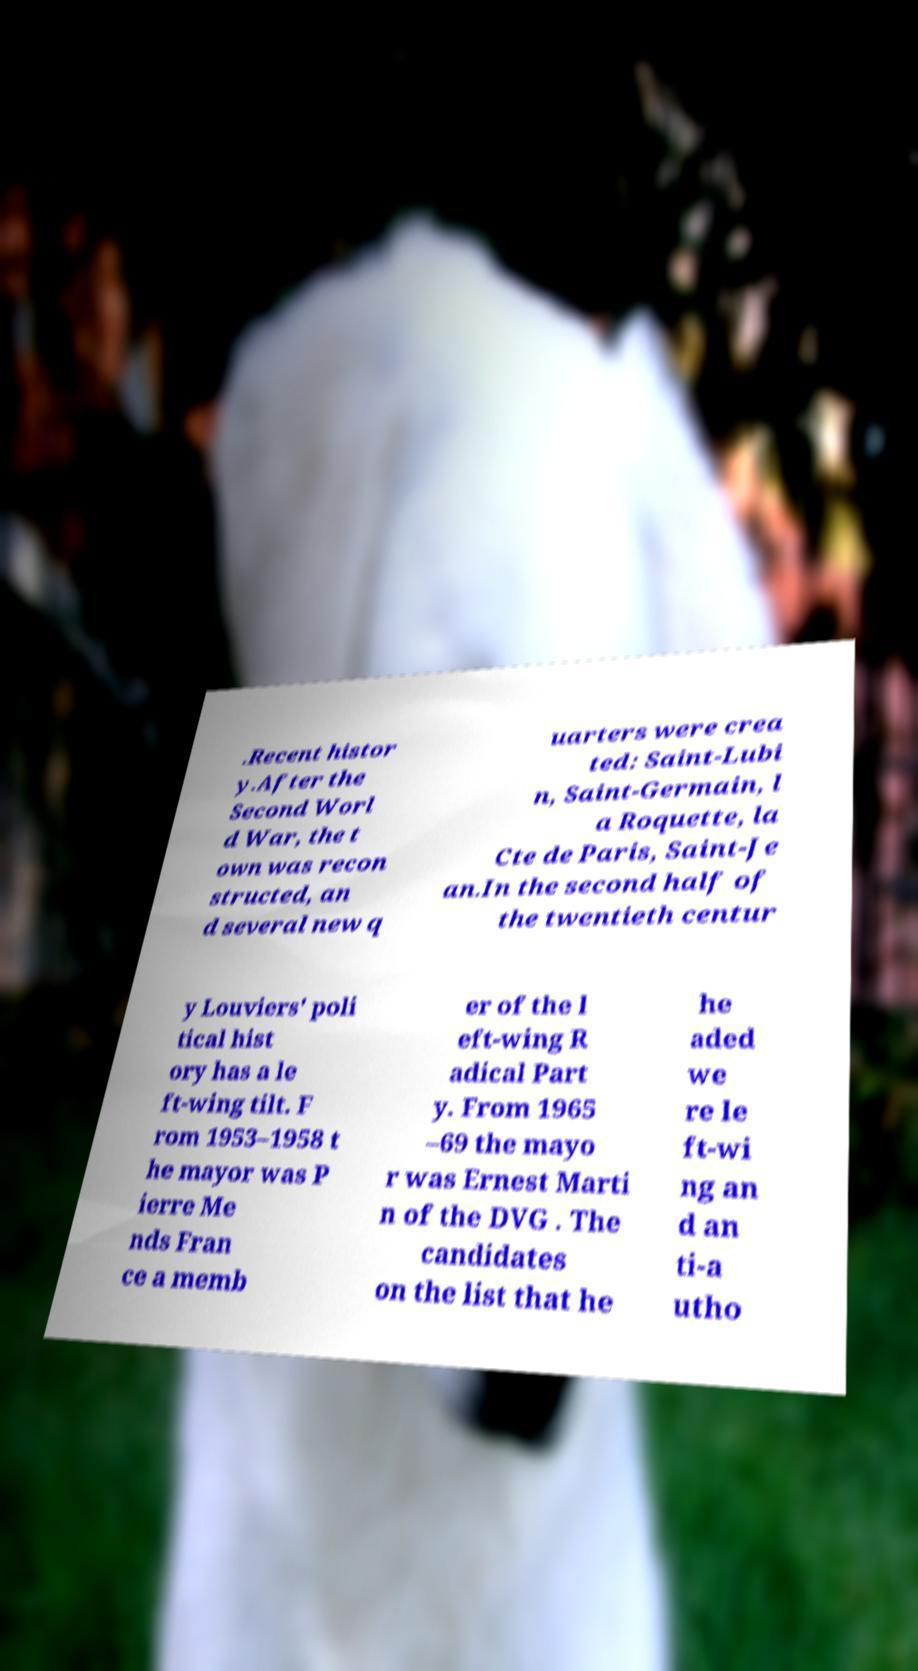Can you accurately transcribe the text from the provided image for me? .Recent histor y.After the Second Worl d War, the t own was recon structed, an d several new q uarters were crea ted: Saint-Lubi n, Saint-Germain, l a Roquette, la Cte de Paris, Saint-Je an.In the second half of the twentieth centur y Louviers' poli tical hist ory has a le ft-wing tilt. F rom 1953–1958 t he mayor was P ierre Me nds Fran ce a memb er of the l eft-wing R adical Part y. From 1965 –69 the mayo r was Ernest Marti n of the DVG . The candidates on the list that he he aded we re le ft-wi ng an d an ti-a utho 